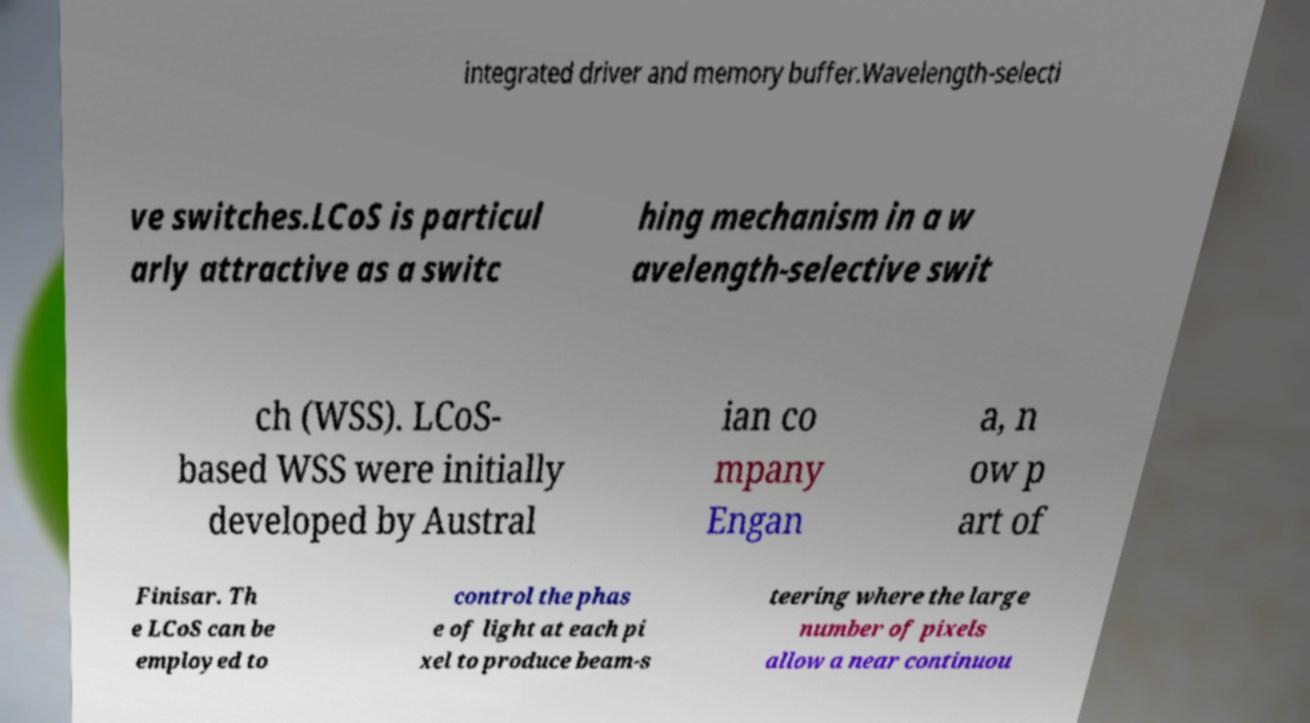What messages or text are displayed in this image? I need them in a readable, typed format. integrated driver and memory buffer.Wavelength-selecti ve switches.LCoS is particul arly attractive as a switc hing mechanism in a w avelength-selective swit ch (WSS). LCoS- based WSS were initially developed by Austral ian co mpany Engan a, n ow p art of Finisar. Th e LCoS can be employed to control the phas e of light at each pi xel to produce beam-s teering where the large number of pixels allow a near continuou 